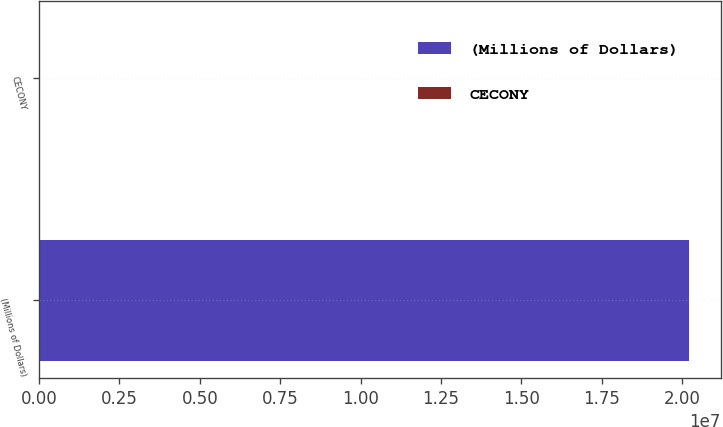Convert chart to OTSL. <chart><loc_0><loc_0><loc_500><loc_500><bar_chart><fcel>(Millions of Dollars)<fcel>CECONY<nl><fcel>2.0192e+07<fcel>3280<nl></chart> 